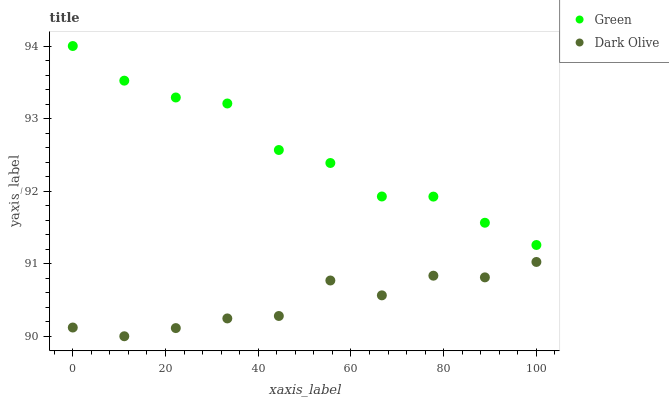Does Dark Olive have the minimum area under the curve?
Answer yes or no. Yes. Does Green have the maximum area under the curve?
Answer yes or no. Yes. Does Green have the minimum area under the curve?
Answer yes or no. No. Is Dark Olive the smoothest?
Answer yes or no. Yes. Is Green the roughest?
Answer yes or no. Yes. Is Green the smoothest?
Answer yes or no. No. Does Dark Olive have the lowest value?
Answer yes or no. Yes. Does Green have the lowest value?
Answer yes or no. No. Does Green have the highest value?
Answer yes or no. Yes. Is Dark Olive less than Green?
Answer yes or no. Yes. Is Green greater than Dark Olive?
Answer yes or no. Yes. Does Dark Olive intersect Green?
Answer yes or no. No. 